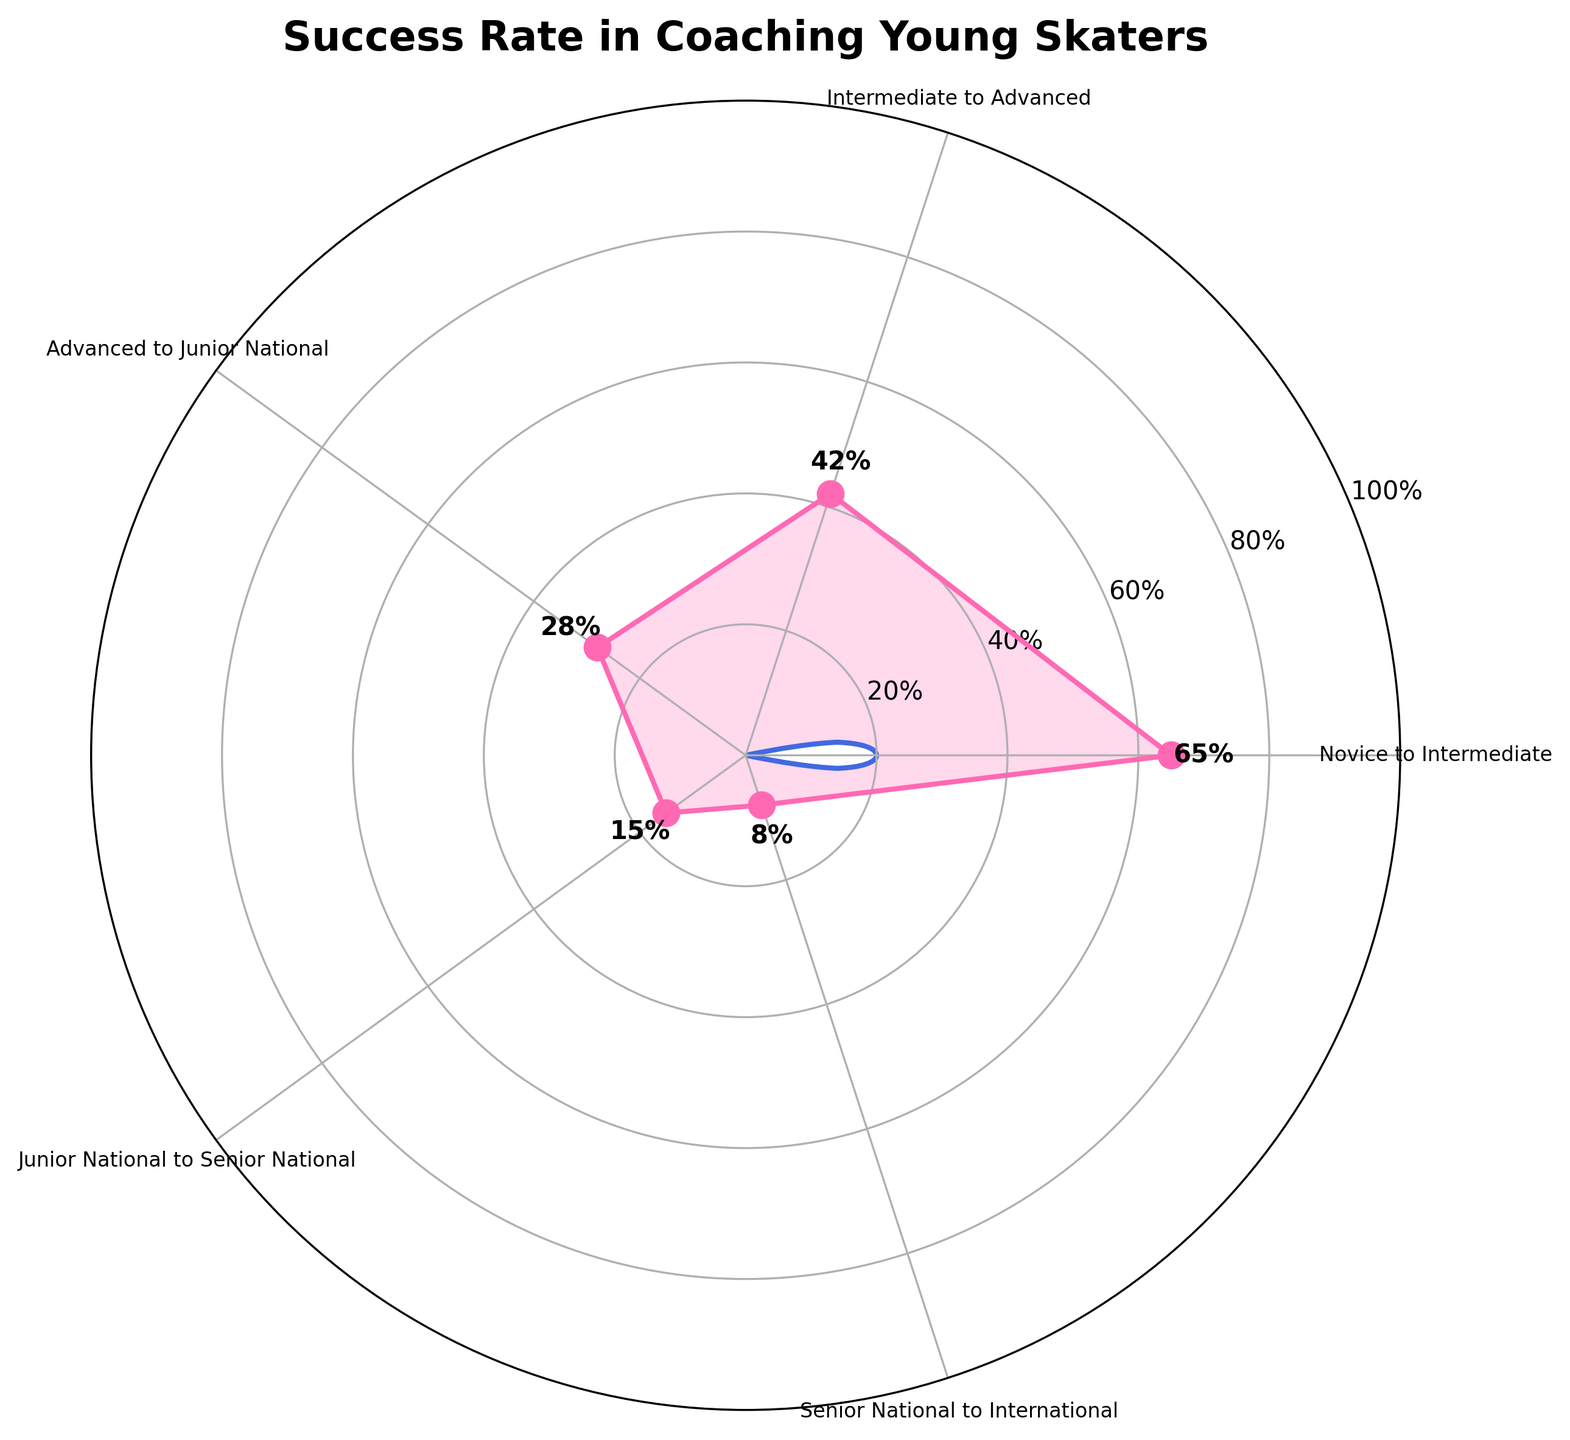What's the title of the figure? The title is the text at the top of the figure. Here, it states "Success Rate in Coaching Young Skaters".
Answer: Success Rate in Coaching Young Skaters What is the success rate from Novice to Intermediate? Look for the data point labeled "Novice to Intermediate" and read the percentage next to it, which is labeled as 65%.
Answer: 65% Which transition has the lowest success rate? Compare the success rates of all transitions and find the smallest value, which is for "Senior National to International" at 8%.
Answer: Senior National to International How many categories of success rates are shown in the figure? Count the distinct categories on the polar plot. They are Novice to Intermediate, Intermediate to Advanced, Advanced to Junior National, Junior National to Senior National, and Senior National to International.
Answer: 5 What is the difference in success rates between Intermediate to Advanced and Advanced to Junior National? Subtract the success rate of Advanced to Junior National (28%) from the success rate of Intermediate to Advanced (42%), which gives 42% - 28%.
Answer: 14% What is the average success rate across all the transitions? Sum all the success rates (65% + 42% + 28% + 15% + 8%) and divide by the number of transitions (5). Calculate: (65 + 42 + 28 + 15 + 8) / 5 = 158 / 5.
Answer: 31.6% Which transition has a higher success rate: Junior National to Senior National or Advanced to Junior National? Compare the success rates of Junior National to Senior National (15%) with Advanced to Junior National (28%). The latter is higher.
Answer: Advanced to Junior National What is the combined success rate for the first three transitions? Add the success rates for Novice to Intermediate (65%), Intermediate to Advanced (42%), and Advanced to Junior National (28%). Calculate: 65 + 42 + 28.
Answer: 135% What color is used to represent the success rates on the plot? Observe the color used to draw the line and fill the area in the polar plot, which is a pink hue likely approximating to pink (not coding terminology).
Answer: Pink 